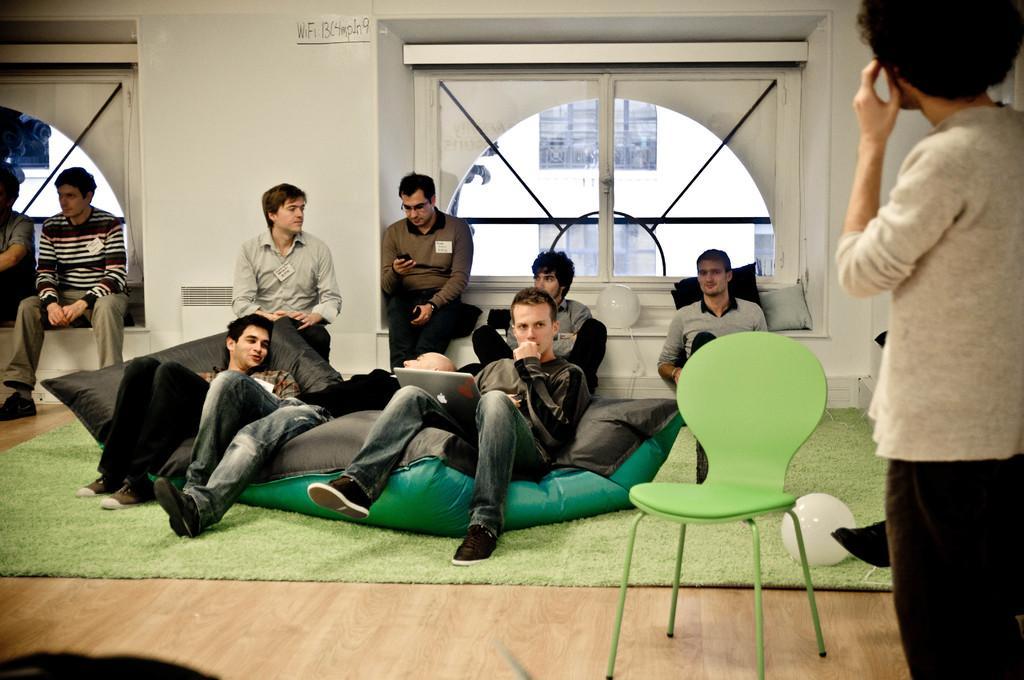In one or two sentences, can you explain what this image depicts? In this image I can see people where one is standing and rest all are sitting. I can also see a chair, a laptop and few cushions. 